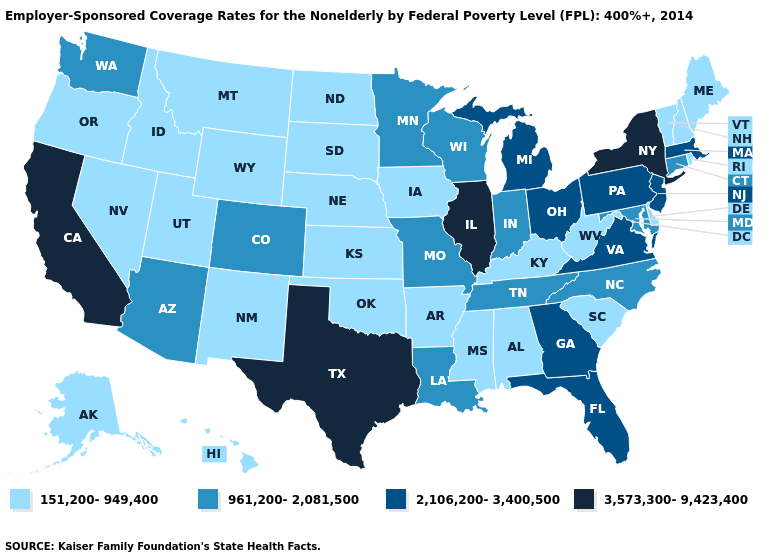Does the map have missing data?
Short answer required. No. Name the states that have a value in the range 2,106,200-3,400,500?
Give a very brief answer. Florida, Georgia, Massachusetts, Michigan, New Jersey, Ohio, Pennsylvania, Virginia. Which states have the lowest value in the USA?
Write a very short answer. Alabama, Alaska, Arkansas, Delaware, Hawaii, Idaho, Iowa, Kansas, Kentucky, Maine, Mississippi, Montana, Nebraska, Nevada, New Hampshire, New Mexico, North Dakota, Oklahoma, Oregon, Rhode Island, South Carolina, South Dakota, Utah, Vermont, West Virginia, Wyoming. Among the states that border Wyoming , does Nebraska have the lowest value?
Quick response, please. Yes. Does the map have missing data?
Answer briefly. No. Does the first symbol in the legend represent the smallest category?
Keep it brief. Yes. Name the states that have a value in the range 2,106,200-3,400,500?
Write a very short answer. Florida, Georgia, Massachusetts, Michigan, New Jersey, Ohio, Pennsylvania, Virginia. Name the states that have a value in the range 961,200-2,081,500?
Keep it brief. Arizona, Colorado, Connecticut, Indiana, Louisiana, Maryland, Minnesota, Missouri, North Carolina, Tennessee, Washington, Wisconsin. Does South Carolina have the same value as Pennsylvania?
Write a very short answer. No. Is the legend a continuous bar?
Answer briefly. No. What is the value of Arizona?
Keep it brief. 961,200-2,081,500. Does New Mexico have a higher value than Rhode Island?
Keep it brief. No. Among the states that border Massachusetts , does Rhode Island have the highest value?
Quick response, please. No. Which states have the lowest value in the USA?
Concise answer only. Alabama, Alaska, Arkansas, Delaware, Hawaii, Idaho, Iowa, Kansas, Kentucky, Maine, Mississippi, Montana, Nebraska, Nevada, New Hampshire, New Mexico, North Dakota, Oklahoma, Oregon, Rhode Island, South Carolina, South Dakota, Utah, Vermont, West Virginia, Wyoming. Name the states that have a value in the range 961,200-2,081,500?
Be succinct. Arizona, Colorado, Connecticut, Indiana, Louisiana, Maryland, Minnesota, Missouri, North Carolina, Tennessee, Washington, Wisconsin. 